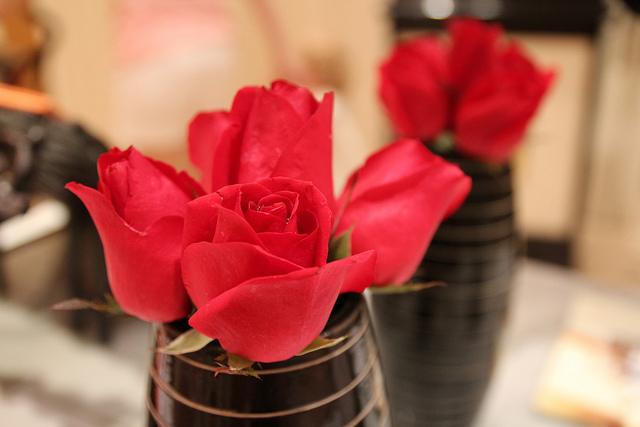Are the flowers real?
Quick response, please. Yes. What type of flower is in the vase?
Keep it brief. Rose. Are all the flowers the same color?
Give a very brief answer. Yes. What holiday are these flowers commonly associated with?
Short answer required. Valentine's day. What color are the flowers?
Concise answer only. Red. Are the flowers made of clay?
Write a very short answer. No. 